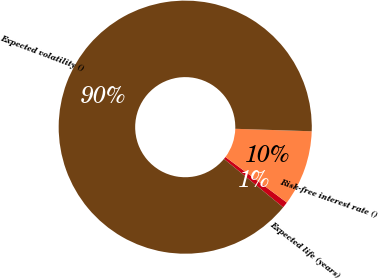<chart> <loc_0><loc_0><loc_500><loc_500><pie_chart><fcel>Expected life (years)<fcel>Risk-free interest rate ()<fcel>Expected volatility ()<nl><fcel>0.76%<fcel>9.64%<fcel>89.6%<nl></chart> 